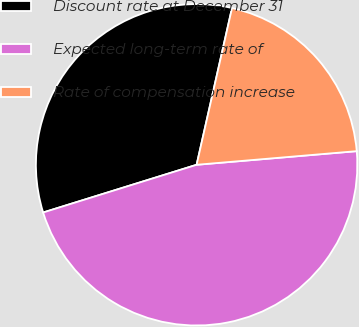Convert chart to OTSL. <chart><loc_0><loc_0><loc_500><loc_500><pie_chart><fcel>Discount rate at December 31<fcel>Expected long-term rate of<fcel>Rate of compensation increase<nl><fcel>33.33%<fcel>46.55%<fcel>20.11%<nl></chart> 